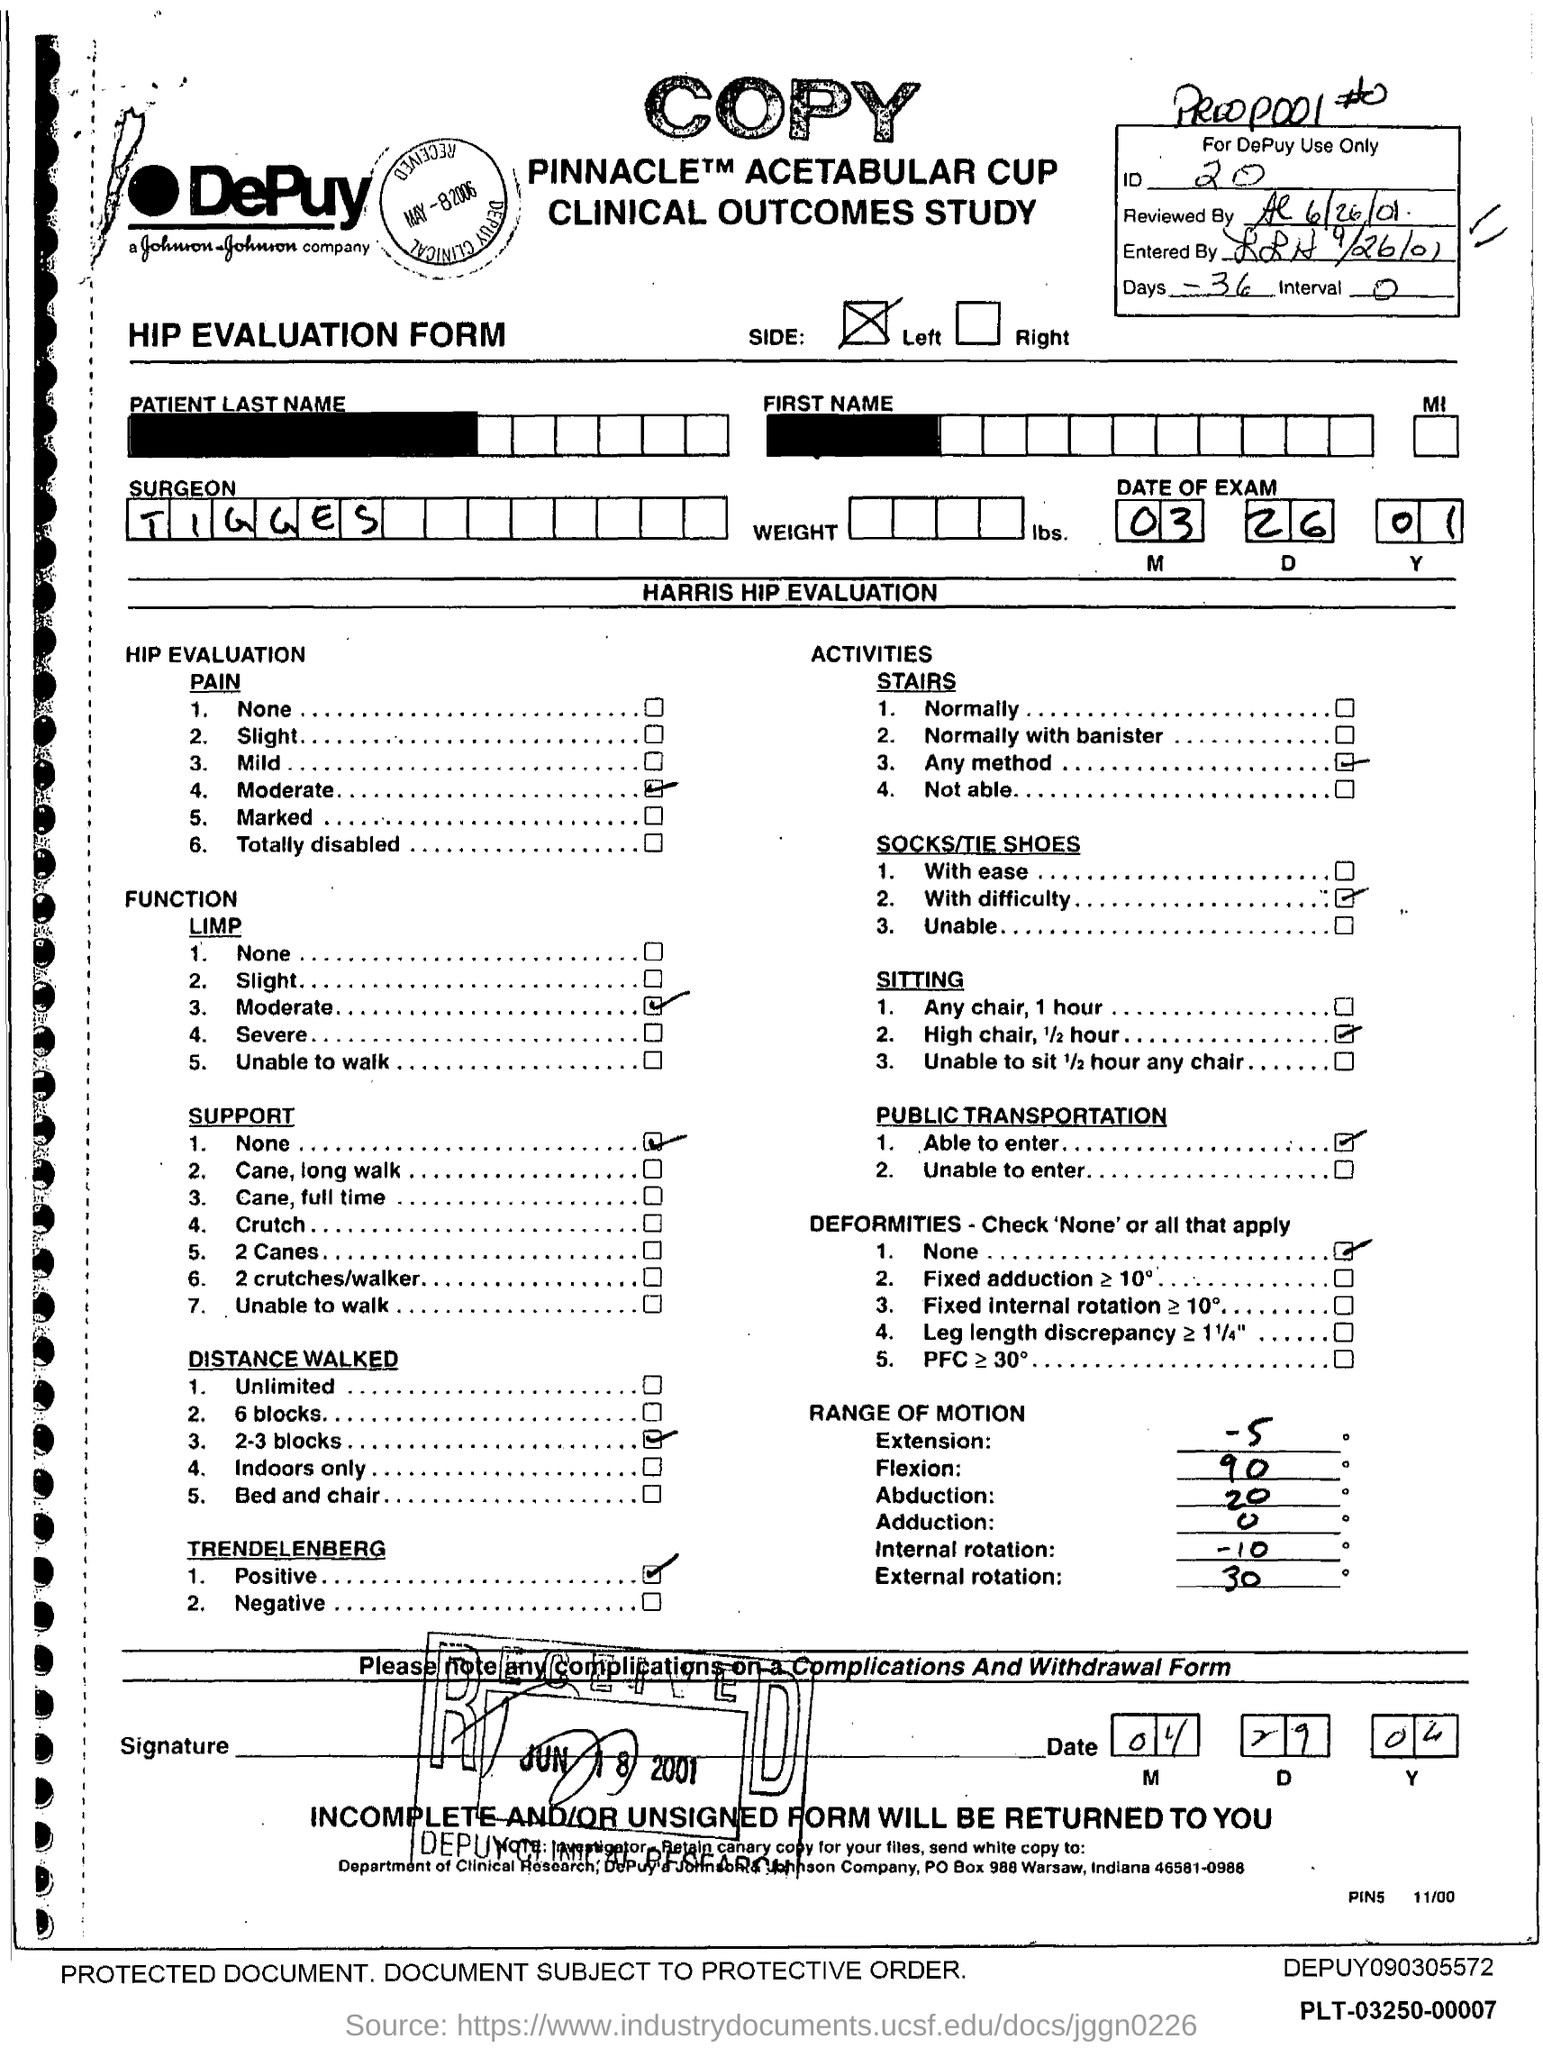Highlight a few significant elements in this photo. The PO box number for Johnson & Johnson Company is 988. The surgeon's name is Tigges. What is the ID number?" is the question being asked. The number in question is 20. Johnson & Johnson is located in the state of Indiana. 